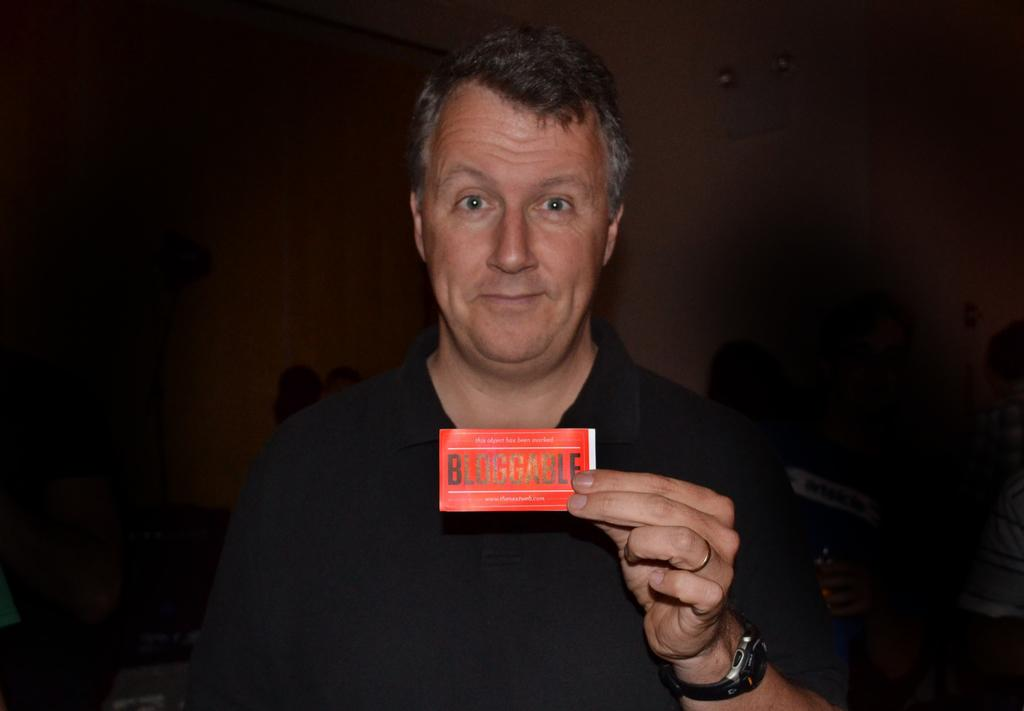What is the main subject of the image? There is a person in the image. What is the person wearing? The person is wearing a black T-shirt. What is the person holding in the image? The person is holding a card. What accessory can be seen on the person's wrist? The person is wearing a watch. Can you describe the background of the image? There is a wall in the background. What type of frame is visible around the person in the image? There is no frame visible around the person in the image; it is a photograph or illustration without a frame. What type of desk can be seen behind the person in the image? There is no desk present in the image; only a wall is visible in the background. 